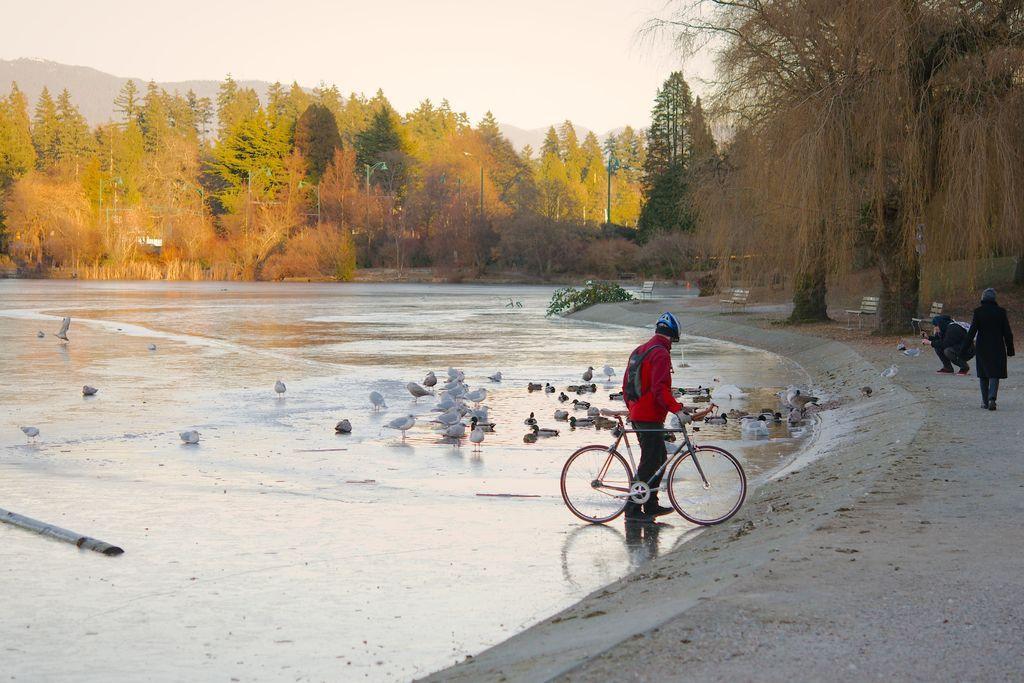Can you describe this image briefly? In this image there is a person with bicycle is present on the surface of the water. There are many birds and also trees visible in this image. Image also consists of benches, poles and a mountain. On the right there are two persons present on the ground. Sky is also visible. 